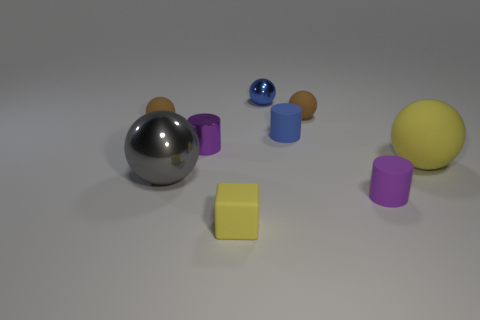Are there any other things that have the same size as the gray metallic sphere?
Your answer should be very brief. Yes. What number of blocks are either small brown matte objects or tiny blue things?
Offer a very short reply. 0. How many objects are brown matte things that are on the left side of the small block or tiny purple matte cylinders?
Ensure brevity in your answer.  2. What is the shape of the tiny blue object behind the brown matte sphere left of the tiny cylinder that is to the left of the tiny matte cube?
Provide a short and direct response. Sphere. What number of other small rubber things have the same shape as the tiny blue rubber thing?
Ensure brevity in your answer.  1. Is the material of the gray ball the same as the yellow sphere?
Your response must be concise. No. There is a yellow cube that is left of the yellow rubber thing that is behind the purple matte cylinder; what number of yellow cubes are right of it?
Your answer should be compact. 0. Is there another tiny cylinder made of the same material as the blue cylinder?
Offer a very short reply. Yes. What is the size of the thing that is the same color as the small rubber cube?
Your answer should be very brief. Large. Are there fewer brown objects than small spheres?
Make the answer very short. Yes. 